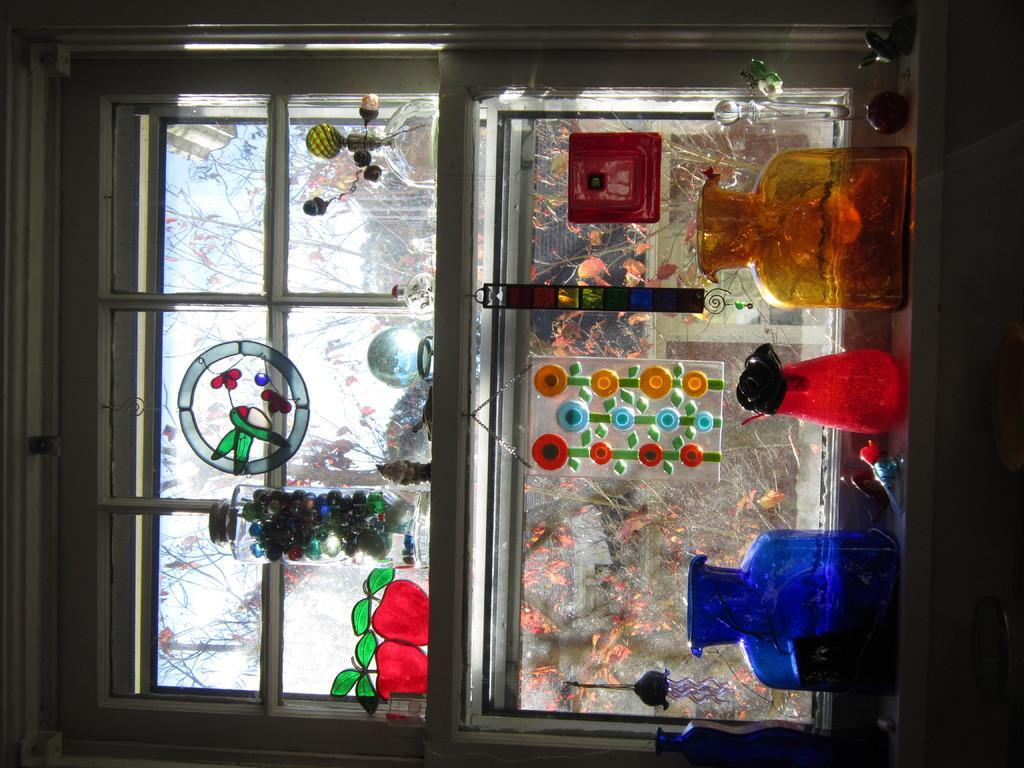Please provide a concise description of this image. On the right of this picture we can see the glass jars and some other objects. In the background we can see the window. On the left we can see the glass jar and some other objects and we can see the pictures of some objects on the window and through the window we can see the sky, trees and some other objects. 